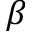<formula> <loc_0><loc_0><loc_500><loc_500>\beta</formula> 